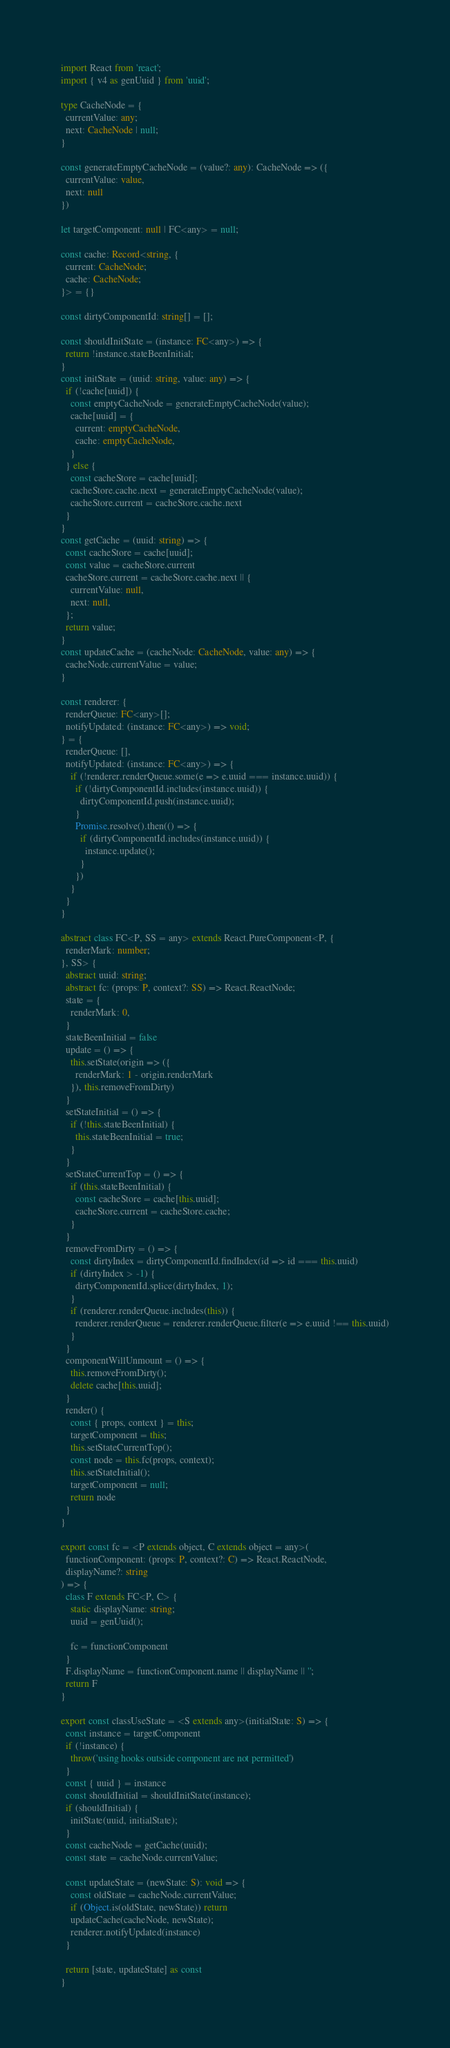<code> <loc_0><loc_0><loc_500><loc_500><_TypeScript_>import React from 'react';
import { v4 as genUuid } from 'uuid';

type CacheNode = {
  currentValue: any;
  next: CacheNode | null;
}

const generateEmptyCacheNode = (value?: any): CacheNode => ({
  currentValue: value,
  next: null
})

let targetComponent: null | FC<any> = null;

const cache: Record<string, {
  current: CacheNode;
  cache: CacheNode;
}> = {}

const dirtyComponentId: string[] = [];

const shouldInitState = (instance: FC<any>) => {
  return !instance.stateBeenInitial;
}
const initState = (uuid: string, value: any) => {
  if (!cache[uuid]) {
    const emptyCacheNode = generateEmptyCacheNode(value);
    cache[uuid] = {
      current: emptyCacheNode,
      cache: emptyCacheNode,
    }
  } else {
    const cacheStore = cache[uuid];
    cacheStore.cache.next = generateEmptyCacheNode(value);
    cacheStore.current = cacheStore.cache.next
  }
}
const getCache = (uuid: string) => {
  const cacheStore = cache[uuid];
  const value = cacheStore.current
  cacheStore.current = cacheStore.cache.next || {
    currentValue: null,
    next: null,
  };
  return value;
}
const updateCache = (cacheNode: CacheNode, value: any) => {
  cacheNode.currentValue = value;
}

const renderer: {
  renderQueue: FC<any>[];
  notifyUpdated: (instance: FC<any>) => void;
} = {
  renderQueue: [],
  notifyUpdated: (instance: FC<any>) => {
    if (!renderer.renderQueue.some(e => e.uuid === instance.uuid)) {
      if (!dirtyComponentId.includes(instance.uuid)) {
        dirtyComponentId.push(instance.uuid);
      }
      Promise.resolve().then(() => {
        if (dirtyComponentId.includes(instance.uuid)) {
          instance.update();
        }
      })
    }
  }
}

abstract class FC<P, SS = any> extends React.PureComponent<P, {
  renderMark: number;
}, SS> {
  abstract uuid: string;
  abstract fc: (props: P, context?: SS) => React.ReactNode;
  state = {
    renderMark: 0,
  }
  stateBeenInitial = false
  update = () => {
    this.setState(origin => ({
      renderMark: 1 - origin.renderMark
    }), this.removeFromDirty)
  }
  setStateInitial = () => {
    if (!this.stateBeenInitial) {
      this.stateBeenInitial = true;
    }
  }
  setStateCurrentTop = () => {
    if (this.stateBeenInitial) {
      const cacheStore = cache[this.uuid];
      cacheStore.current = cacheStore.cache;
    }
  }
  removeFromDirty = () => {
    const dirtyIndex = dirtyComponentId.findIndex(id => id === this.uuid)
    if (dirtyIndex > -1) {
      dirtyComponentId.splice(dirtyIndex, 1);
    }
    if (renderer.renderQueue.includes(this)) {
      renderer.renderQueue = renderer.renderQueue.filter(e => e.uuid !== this.uuid)
    }
  }
  componentWillUnmount = () => {
    this.removeFromDirty();
    delete cache[this.uuid];
  }
  render() {
    const { props, context } = this;
    targetComponent = this;
    this.setStateCurrentTop();
    const node = this.fc(props, context);
    this.setStateInitial();
    targetComponent = null;
    return node
  }
}

export const fc = <P extends object, C extends object = any>(
  functionComponent: (props: P, context?: C) => React.ReactNode,
  displayName?: string
) => {
  class F extends FC<P, C> {
    static displayName: string;
    uuid = genUuid();

    fc = functionComponent
  }
  F.displayName = functionComponent.name || displayName || '';
  return F
}

export const classUseState = <S extends any>(initialState: S) => {
  const instance = targetComponent
  if (!instance) {
    throw('using hooks outside component are not permitted')
  }
  const { uuid } = instance
  const shouldInitial = shouldInitState(instance);
  if (shouldInitial) {
    initState(uuid, initialState);
  }
  const cacheNode = getCache(uuid);
  const state = cacheNode.currentValue;

  const updateState = (newState: S): void => {
    const oldState = cacheNode.currentValue;
    if (Object.is(oldState, newState)) return
    updateCache(cacheNode, newState);
    renderer.notifyUpdated(instance)
  }

  return [state, updateState] as const
}
</code> 